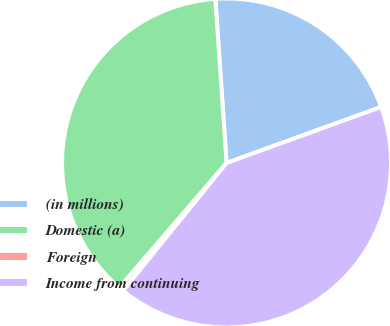Convert chart to OTSL. <chart><loc_0><loc_0><loc_500><loc_500><pie_chart><fcel>(in millions)<fcel>Domestic (a)<fcel>Foreign<fcel>Income from continuing<nl><fcel>20.55%<fcel>37.61%<fcel>0.46%<fcel>41.37%<nl></chart> 